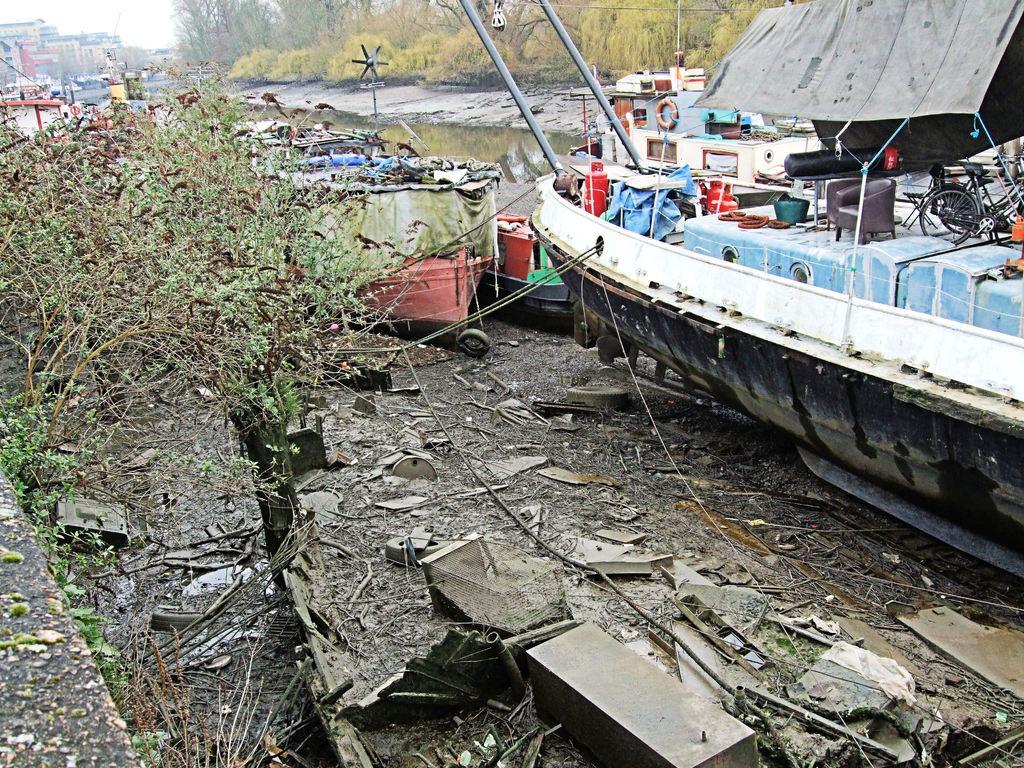Could you give a brief overview of what you see in this image? In this picture i can see many boats near to the water. On the right i can see the bicycle, chair, tire, basket, plastic covers, coat and other objects are kept on the boat. At the bottom i can see the scrap materials. In the background i can see the trees, plants, grass and buildings. in the top left corner there is a sky. 